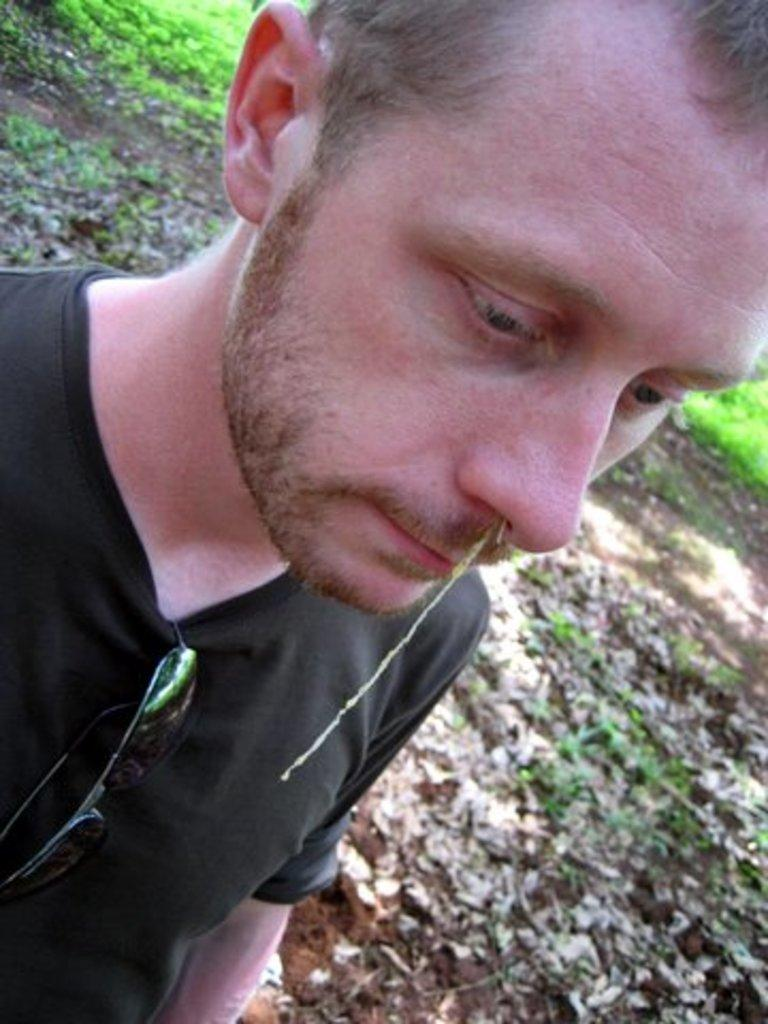Who is present in the image? There is a man in the image. What is the man standing on? The man is standing on a mud path. What is the man wearing on his upper body? The man is wearing a black T-shirt. What type of eyewear is the man wearing? The man is wearing shades. What can be seen in the background of the image? There is a grass surface visible in the background of the image. Is there a hole in the ground that the man is about to fall into in the image? There is no hole in the ground visible in the image, and the man is not shown falling or in any danger. 